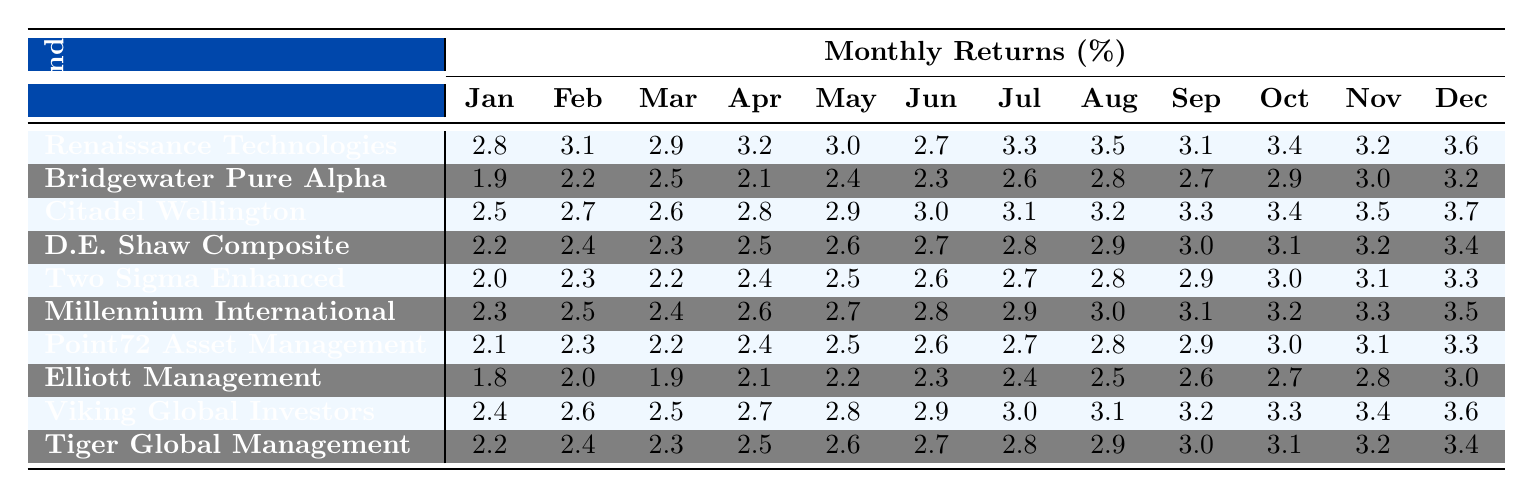What was the highest monthly return for the Renaissance Technologies Medallion Fund? The highest monthly return can be identified by looking across the months for the Renaissance Technologies Medallion Fund. The values in the table are 2.8%, 3.1%, 2.9%, 3.2%, 3.0%, 2.7%, 3.3%, 3.5%, 3.1%, 3.4%, 3.2%, and 3.6%. The maximum value among these is 3.6%.
Answer: 3.6% Which hedge fund had the lowest return in June 2022? In the table, we can find the June returns for each fund. The values are 2.7%, 2.3%, 3.0%, 2.7%, 2.6%, 2.8%, 2.6%, 2.3%, 2.9%, and 2.7%. The lowest return is 2.3%, which belongs to Elliott Management Corporation.
Answer: Elliott Management Corporation What is the average return for Citadel Wellington Fund over the year? The monthly returns for Citadel Wellington Fund are: 2.5%, 2.7%, 2.6%, 2.8%, 2.9%, 3.0%, 3.1%, 3.2%, 3.3%, 3.4%, 3.5%, 3.7%. To find the average, we sum these values which equals 35.1%, and then divide by 12 (the number of months) resulting in an average of 2.925%.
Answer: 2.925% Did Two Sigma Enhanced Compass Fund ever have a return of 3% or higher? We need to check the monthly return values for Two Sigma Enhanced Compass Fund: 2.0%, 2.3%, 2.2%, 2.4%, 2.5%, 2.6%, 2.7%, 2.8%, 2.9%, 3.0%, 3.1%, and 3.3%. The returns of 3.0% (in October) and 3.1% (in November) indicate that this fund did reach 3% returns.
Answer: Yes Which fund had the most consistent returns over the year, looking for the smallest variance? To evaluate consistency, we will consider how close the monthly returns are in value for each fund. After comparing the monthly ranges for each fund, we find that Bridgewater Pure Alpha Fund has the smallest range (1.3% from 1.9% to 3.2%) in returns, suggesting it is the most consistent.
Answer: Bridgewater Pure Alpha Fund What is the total return of the Tiger Global Management for the last six months? The last six months' returns for Tiger Global Management are 3.1%, 3.2%, 3.4%, 3.4%, 3.3%, and 2.9%. Adding these values gives a total of 19.3%.
Answer: 19.3% Which hedge fund had the highest increase from its first month (January) to its last month (December)? To find the highest increase, we check the January and December returns for each fund and calculate the difference. For example, Renaissance Technologies had 2.8% in January and 3.6% in December, which is a difference of 0.8%. Comparing all the differences, we find that Citadel Wellington Fund had the largest increase of 1.2% (from 2.5% to 3.7%).
Answer: Citadel Wellington Fund In which month did Renaissance Technologies achieve its highest return? We need to look for the maximum value in the Renaissance Technologies monthly returns. The numbers show that 3.6% is the highest return, which occurred in December.
Answer: December 